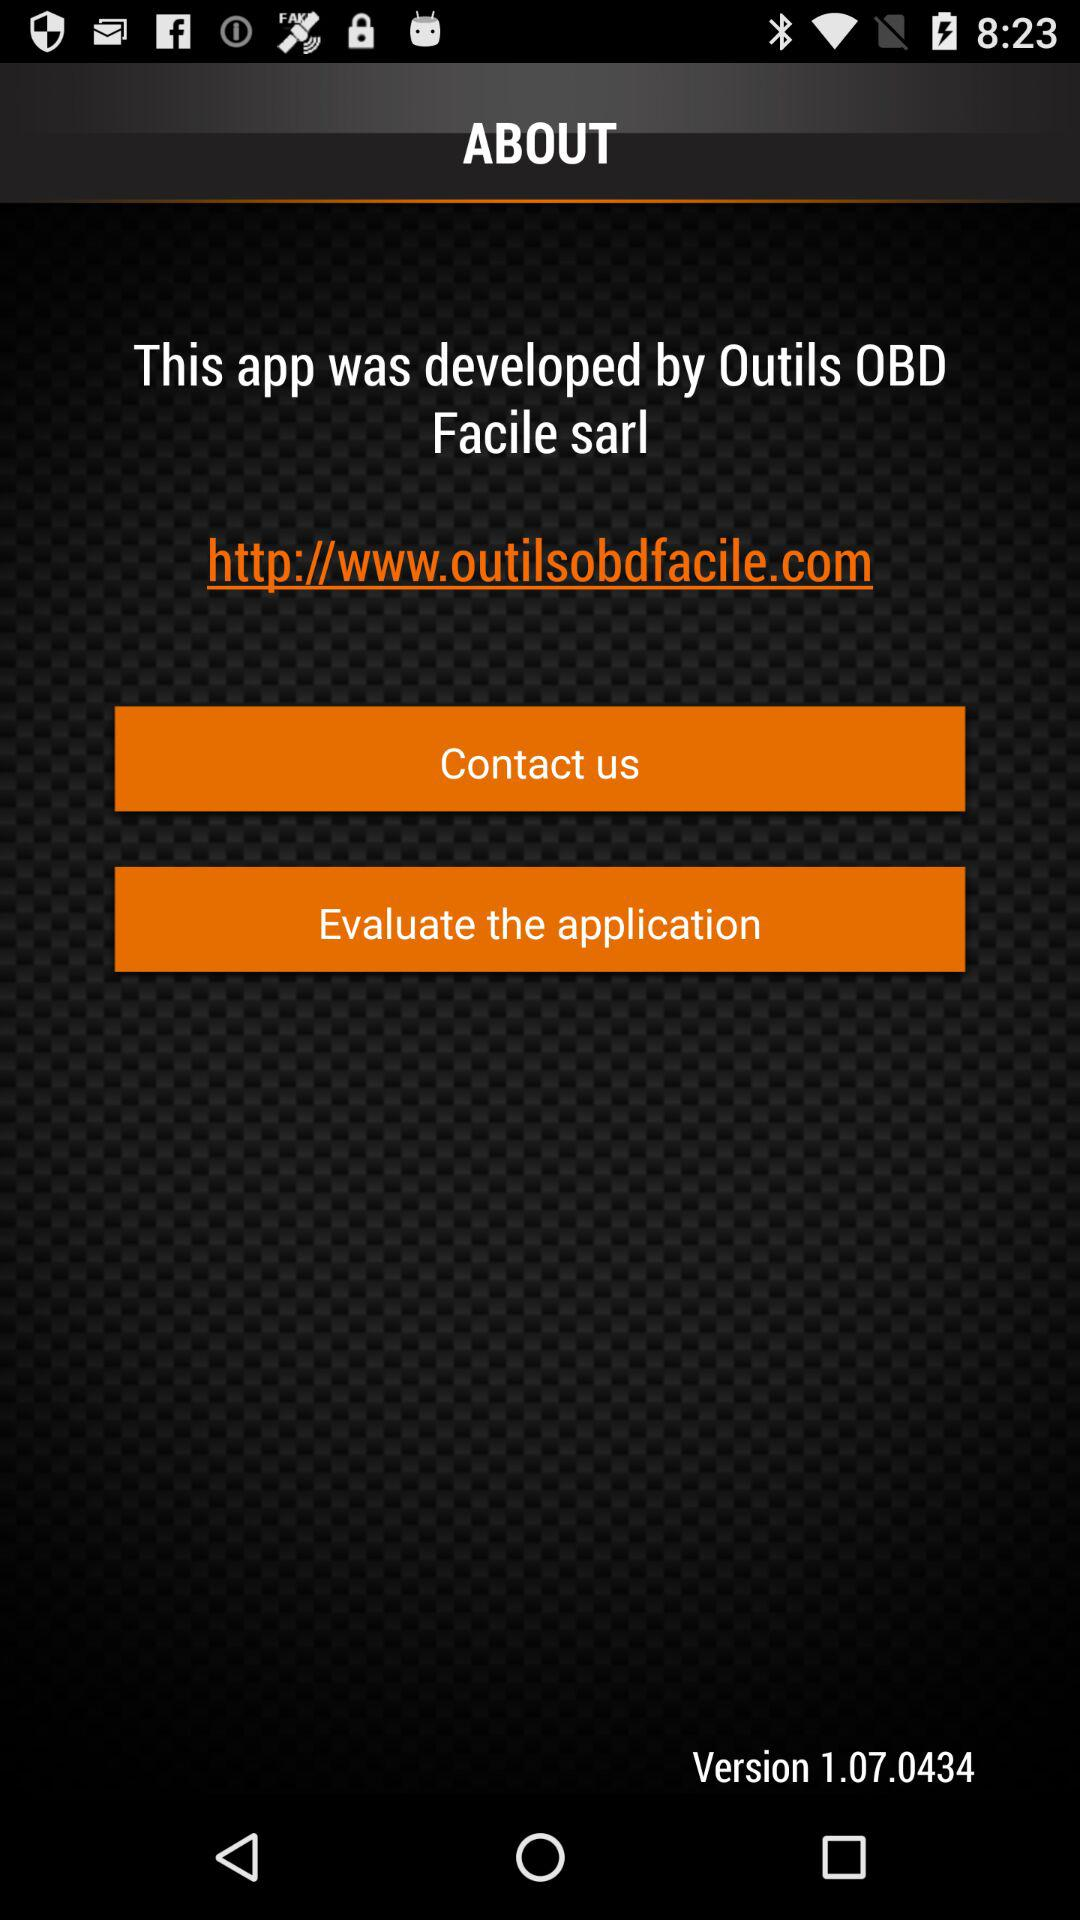Who developed the app? The app is developed by "Outils OBD Facile sarl". 